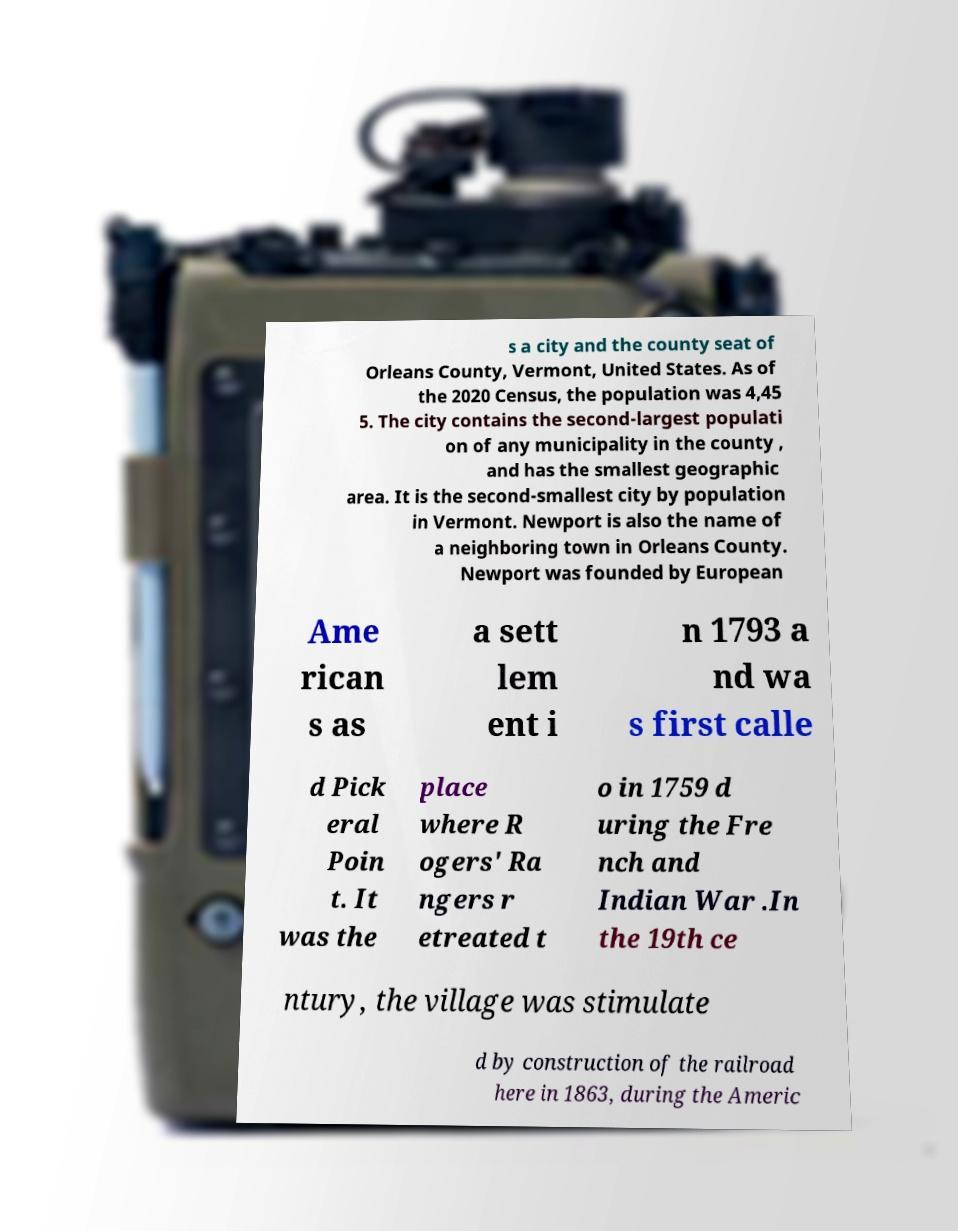Can you read and provide the text displayed in the image?This photo seems to have some interesting text. Can you extract and type it out for me? s a city and the county seat of Orleans County, Vermont, United States. As of the 2020 Census, the population was 4,45 5. The city contains the second-largest populati on of any municipality in the county , and has the smallest geographic area. It is the second-smallest city by population in Vermont. Newport is also the name of a neighboring town in Orleans County. Newport was founded by European Ame rican s as a sett lem ent i n 1793 a nd wa s first calle d Pick eral Poin t. It was the place where R ogers' Ra ngers r etreated t o in 1759 d uring the Fre nch and Indian War .In the 19th ce ntury, the village was stimulate d by construction of the railroad here in 1863, during the Americ 